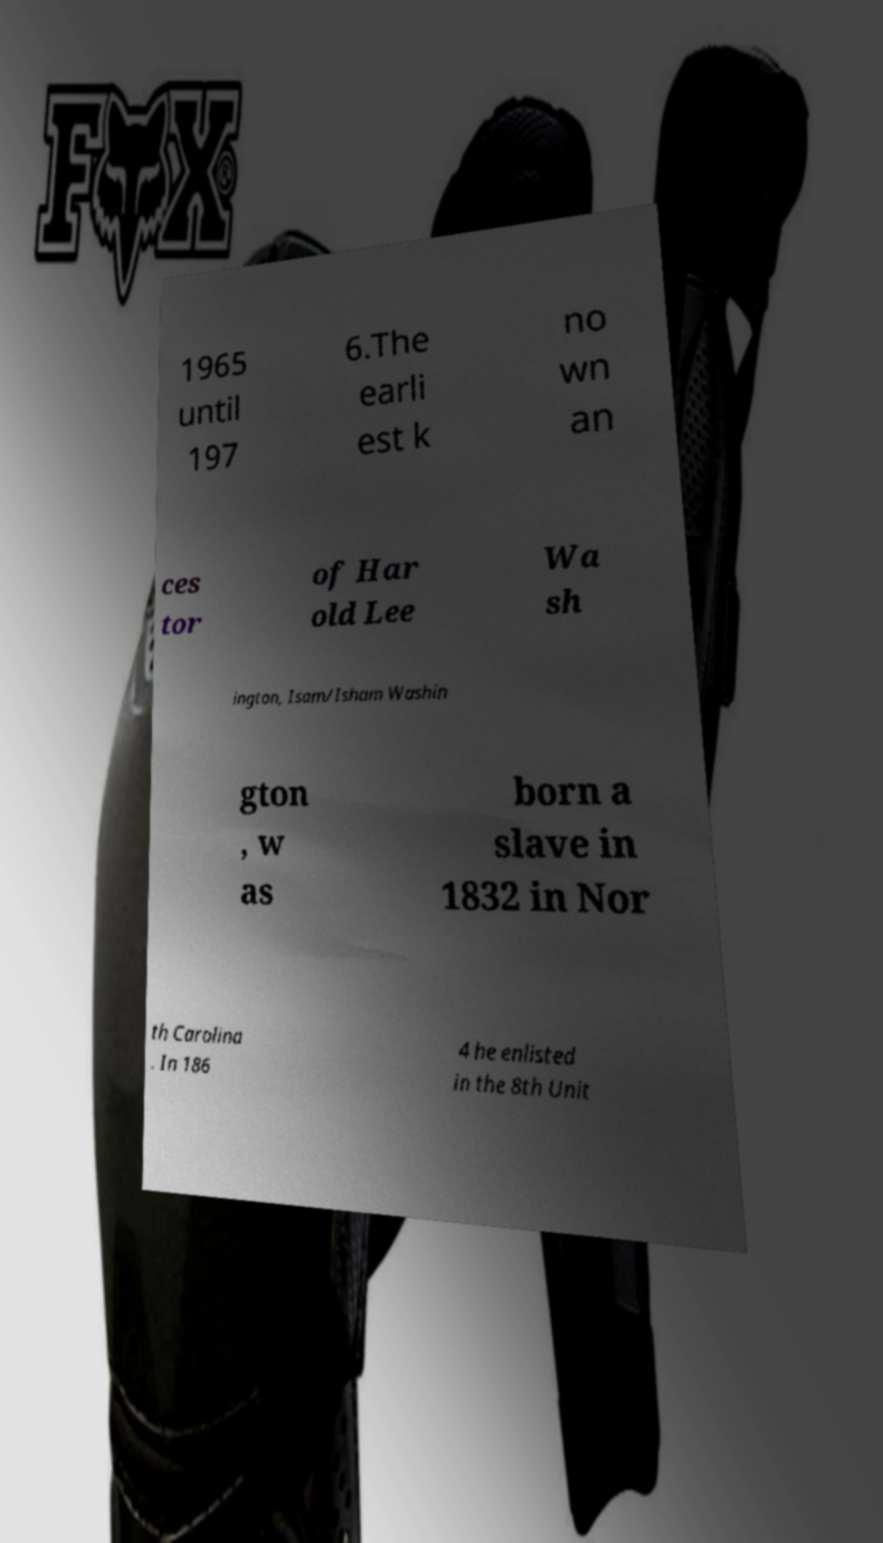Please identify and transcribe the text found in this image. 1965 until 197 6.The earli est k no wn an ces tor of Har old Lee Wa sh ington, Isam/Isham Washin gton , w as born a slave in 1832 in Nor th Carolina . In 186 4 he enlisted in the 8th Unit 